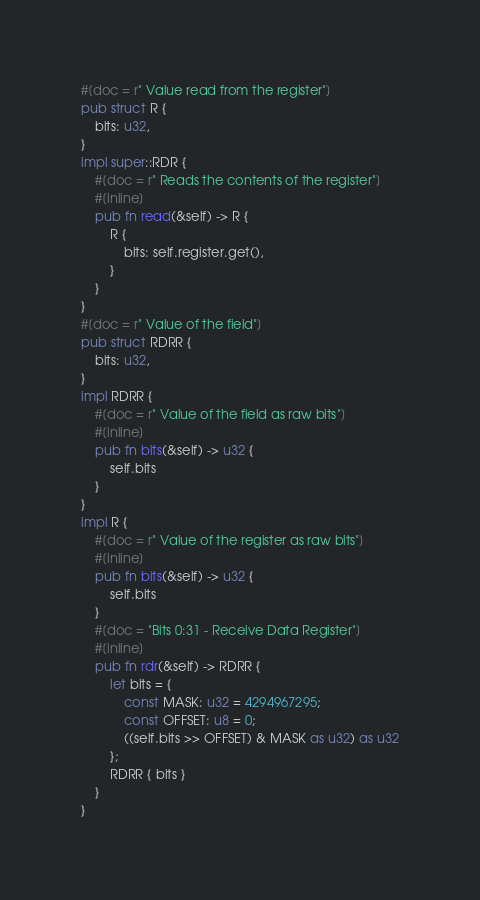Convert code to text. <code><loc_0><loc_0><loc_500><loc_500><_Rust_>#[doc = r" Value read from the register"]
pub struct R {
    bits: u32,
}
impl super::RDR {
    #[doc = r" Reads the contents of the register"]
    #[inline]
    pub fn read(&self) -> R {
        R {
            bits: self.register.get(),
        }
    }
}
#[doc = r" Value of the field"]
pub struct RDRR {
    bits: u32,
}
impl RDRR {
    #[doc = r" Value of the field as raw bits"]
    #[inline]
    pub fn bits(&self) -> u32 {
        self.bits
    }
}
impl R {
    #[doc = r" Value of the register as raw bits"]
    #[inline]
    pub fn bits(&self) -> u32 {
        self.bits
    }
    #[doc = "Bits 0:31 - Receive Data Register"]
    #[inline]
    pub fn rdr(&self) -> RDRR {
        let bits = {
            const MASK: u32 = 4294967295;
            const OFFSET: u8 = 0;
            ((self.bits >> OFFSET) & MASK as u32) as u32
        };
        RDRR { bits }
    }
}
</code> 